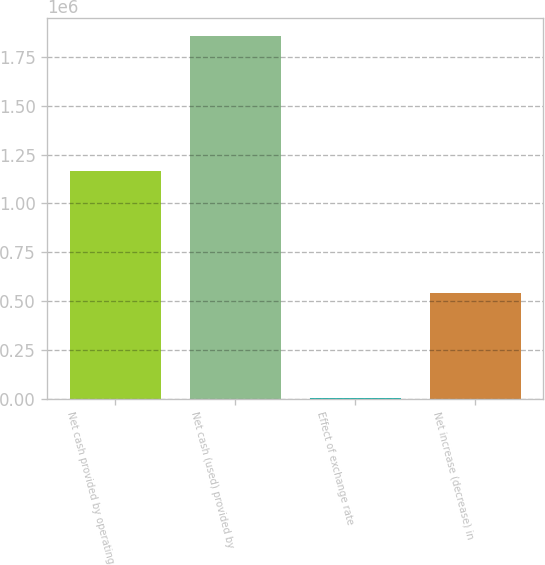Convert chart to OTSL. <chart><loc_0><loc_0><loc_500><loc_500><bar_chart><fcel>Net cash provided by operating<fcel>Net cash (used) provided by<fcel>Effect of exchange rate<fcel>Net increase (decrease) in<nl><fcel>1.16342e+06<fcel>1.85609e+06<fcel>4940<fcel>542295<nl></chart> 